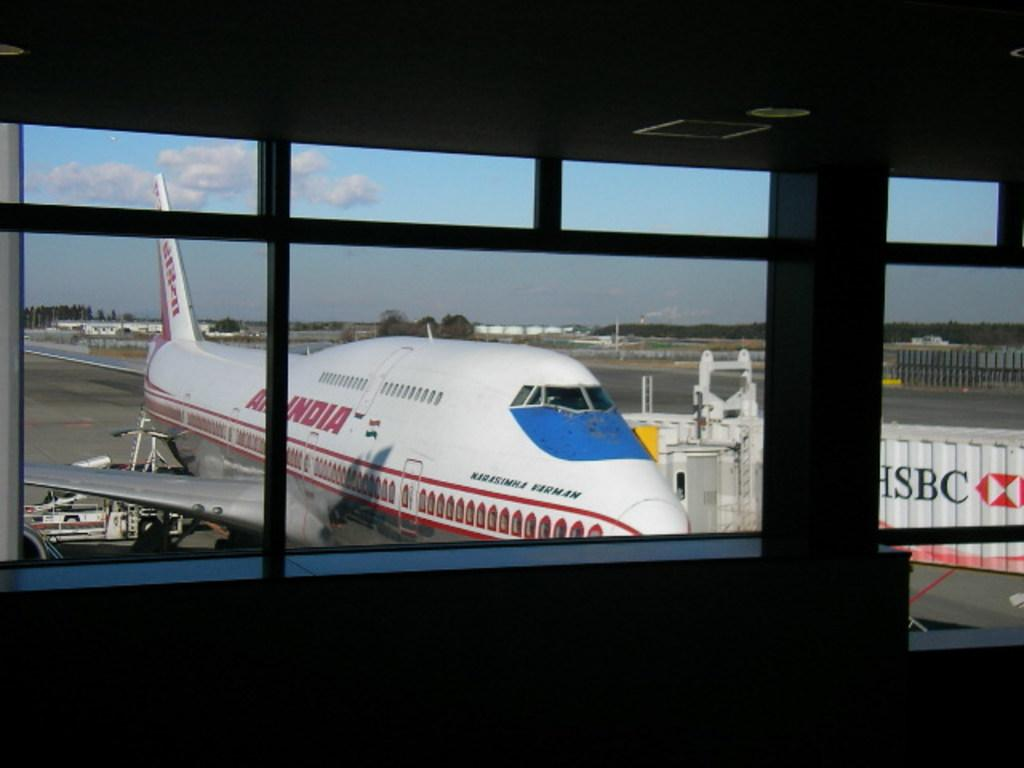<image>
Present a compact description of the photo's key features. A large commercial Air India jet is connected to the airport. 